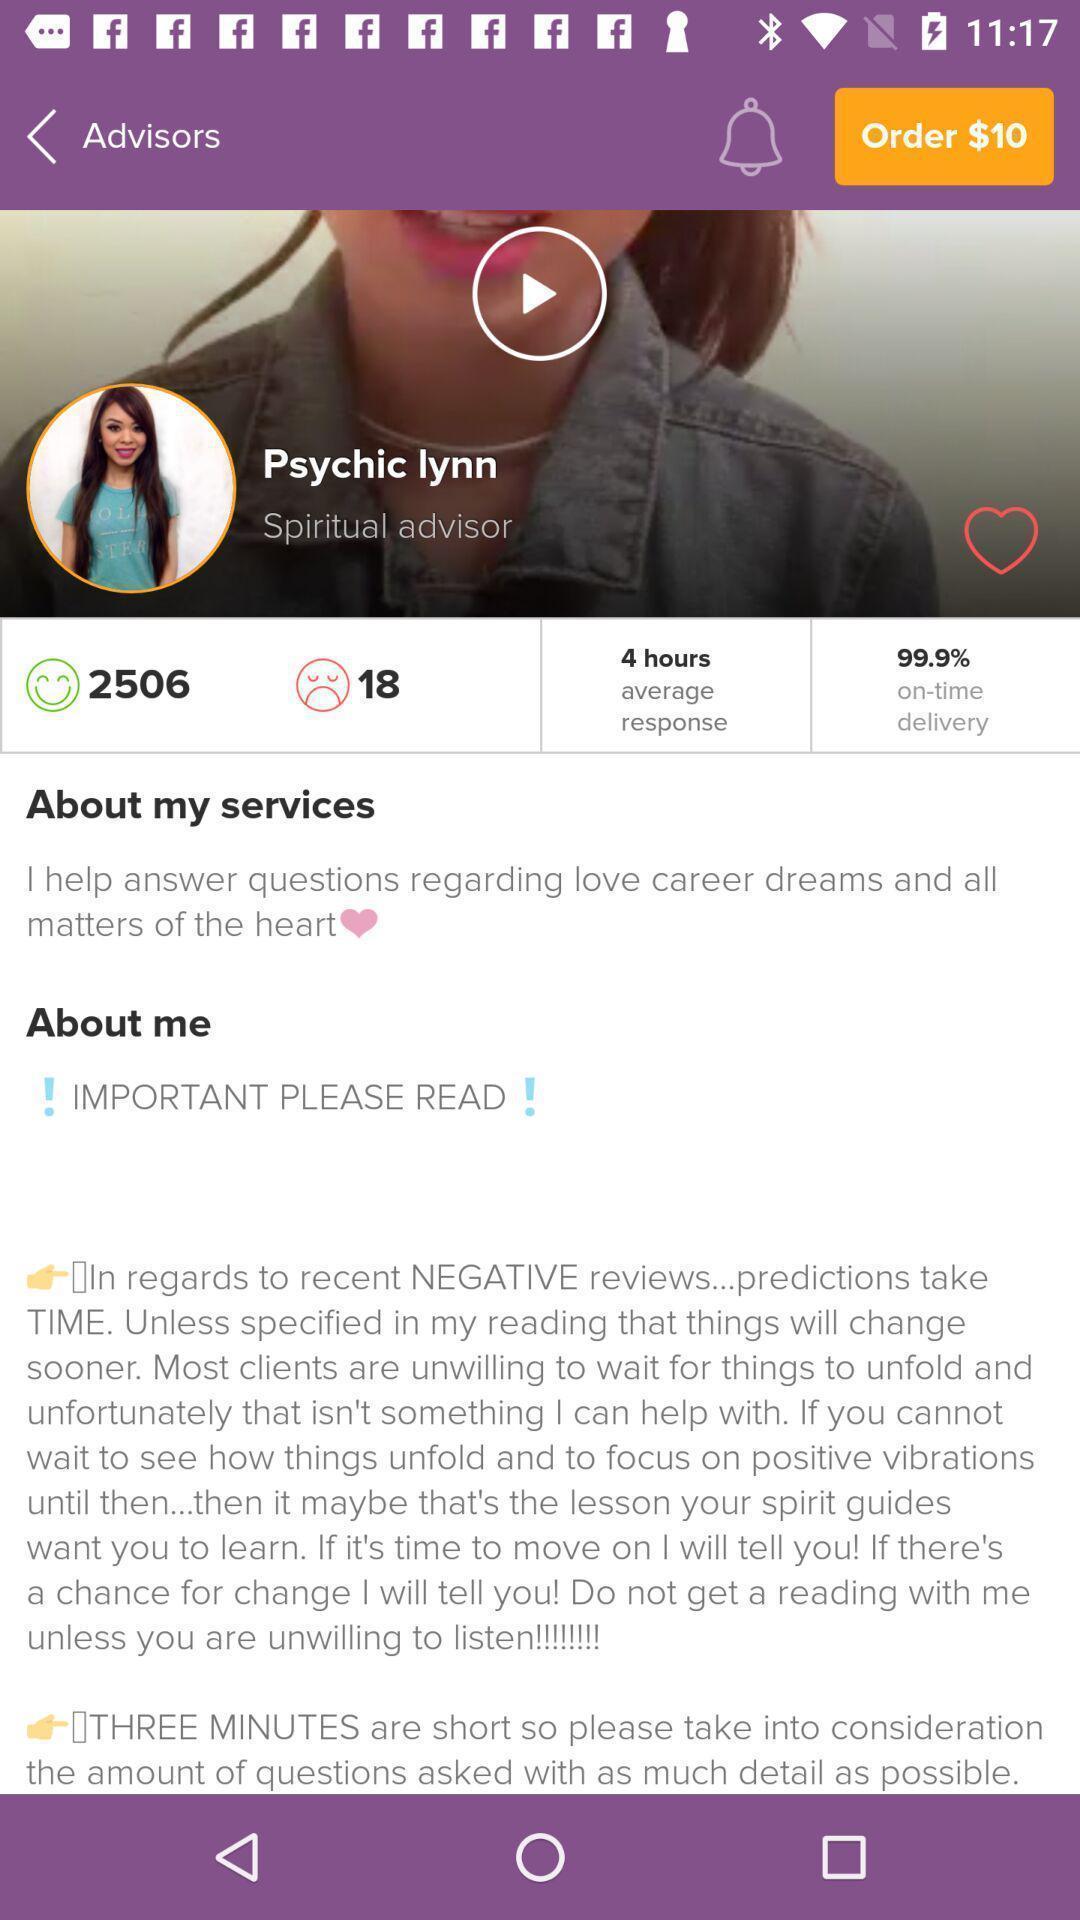Summarize the main components in this picture. Screen showing profile page. 